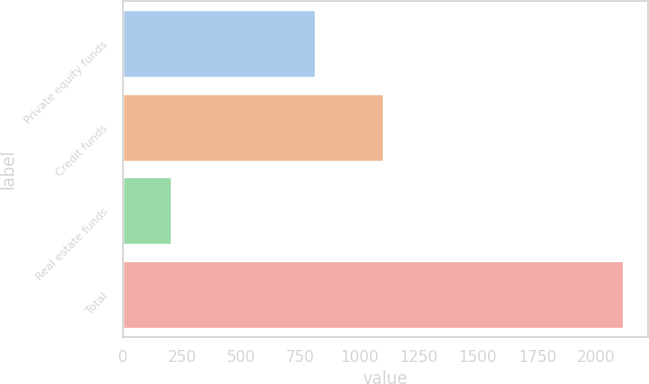<chart> <loc_0><loc_0><loc_500><loc_500><bar_chart><fcel>Private equity funds<fcel>Credit funds<fcel>Real estate funds<fcel>Total<nl><fcel>809<fcel>1099<fcel>203<fcel>2111<nl></chart> 